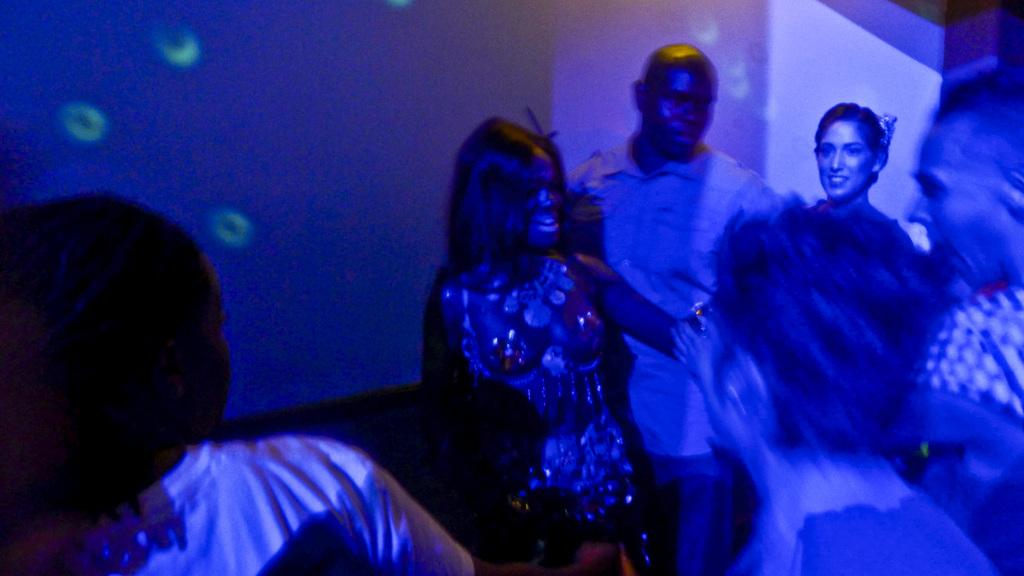What is the main subject of the image? The main subject of the image is people. Can you describe the setting where the people are located? The setting resembles a pub. What is visible in the background of the image? There is a wall in the background of the image. Can you see any harmonies being played in the image? There is no indication of any harmonies being played in the image. Is there a church visible in the image? There is no church present in the image. Are there any ants crawling on the people in the image? There is no mention of ants in the image, and it is highly unlikely that ants would be crawling on people in a pub setting. 